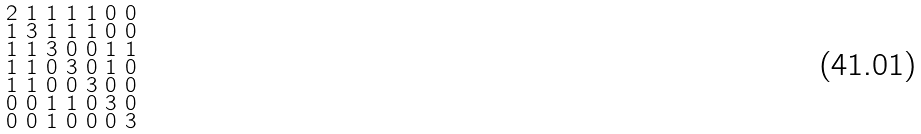Convert formula to latex. <formula><loc_0><loc_0><loc_500><loc_500>\begin{smallmatrix} 2 & 1 & 1 & 1 & 1 & 0 & 0 \\ 1 & 3 & 1 & 1 & 1 & 0 & 0 \\ 1 & 1 & 3 & 0 & 0 & 1 & 1 \\ 1 & 1 & 0 & 3 & 0 & 1 & 0 \\ 1 & 1 & 0 & 0 & 3 & 0 & 0 \\ 0 & 0 & 1 & 1 & 0 & 3 & 0 \\ 0 & 0 & 1 & 0 & 0 & 0 & 3 \end{smallmatrix}</formula> 